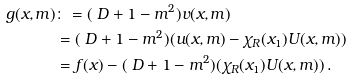<formula> <loc_0><loc_0><loc_500><loc_500>g ( x , m ) & \colon = ( \ D + 1 - m ^ { 2 } ) v ( x , m ) \\ & = ( \ D + 1 - m ^ { 2 } ) ( u ( x , m ) - \chi _ { R } ( x _ { 1 } ) U ( x , m ) ) \\ & = f ( x ) - ( \ D + 1 - m ^ { 2 } ) ( \chi _ { R } ( x _ { 1 } ) U ( x , m ) ) \, .</formula> 